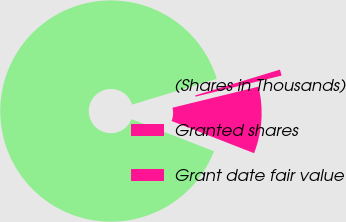<chart> <loc_0><loc_0><loc_500><loc_500><pie_chart><fcel>(Shares in Thousands)<fcel>Granted shares<fcel>Grant date fair value<nl><fcel>89.38%<fcel>0.89%<fcel>9.74%<nl></chart> 